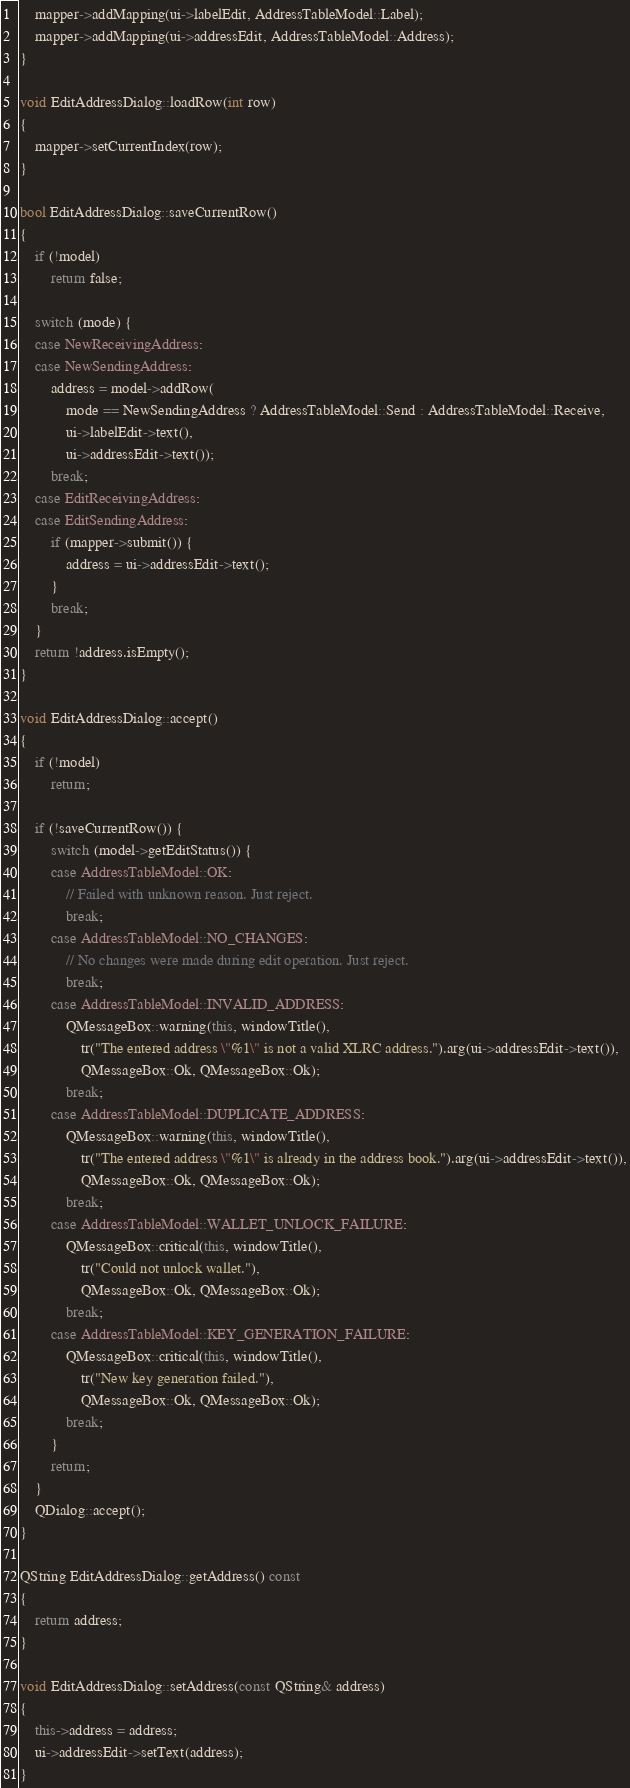<code> <loc_0><loc_0><loc_500><loc_500><_C++_>    mapper->addMapping(ui->labelEdit, AddressTableModel::Label);
    mapper->addMapping(ui->addressEdit, AddressTableModel::Address);
}

void EditAddressDialog::loadRow(int row)
{
    mapper->setCurrentIndex(row);
}

bool EditAddressDialog::saveCurrentRow()
{
    if (!model)
        return false;

    switch (mode) {
    case NewReceivingAddress:
    case NewSendingAddress:
        address = model->addRow(
            mode == NewSendingAddress ? AddressTableModel::Send : AddressTableModel::Receive,
            ui->labelEdit->text(),
            ui->addressEdit->text());
        break;
    case EditReceivingAddress:
    case EditSendingAddress:
        if (mapper->submit()) {
            address = ui->addressEdit->text();
        }
        break;
    }
    return !address.isEmpty();
}

void EditAddressDialog::accept()
{
    if (!model)
        return;

    if (!saveCurrentRow()) {
        switch (model->getEditStatus()) {
        case AddressTableModel::OK:
            // Failed with unknown reason. Just reject.
            break;
        case AddressTableModel::NO_CHANGES:
            // No changes were made during edit operation. Just reject.
            break;
        case AddressTableModel::INVALID_ADDRESS:
            QMessageBox::warning(this, windowTitle(),
                tr("The entered address \"%1\" is not a valid XLRC address.").arg(ui->addressEdit->text()),
                QMessageBox::Ok, QMessageBox::Ok);
            break;
        case AddressTableModel::DUPLICATE_ADDRESS:
            QMessageBox::warning(this, windowTitle(),
                tr("The entered address \"%1\" is already in the address book.").arg(ui->addressEdit->text()),
                QMessageBox::Ok, QMessageBox::Ok);
            break;
        case AddressTableModel::WALLET_UNLOCK_FAILURE:
            QMessageBox::critical(this, windowTitle(),
                tr("Could not unlock wallet."),
                QMessageBox::Ok, QMessageBox::Ok);
            break;
        case AddressTableModel::KEY_GENERATION_FAILURE:
            QMessageBox::critical(this, windowTitle(),
                tr("New key generation failed."),
                QMessageBox::Ok, QMessageBox::Ok);
            break;
        }
        return;
    }
    QDialog::accept();
}

QString EditAddressDialog::getAddress() const
{
    return address;
}

void EditAddressDialog::setAddress(const QString& address)
{
    this->address = address;
    ui->addressEdit->setText(address);
}
</code> 